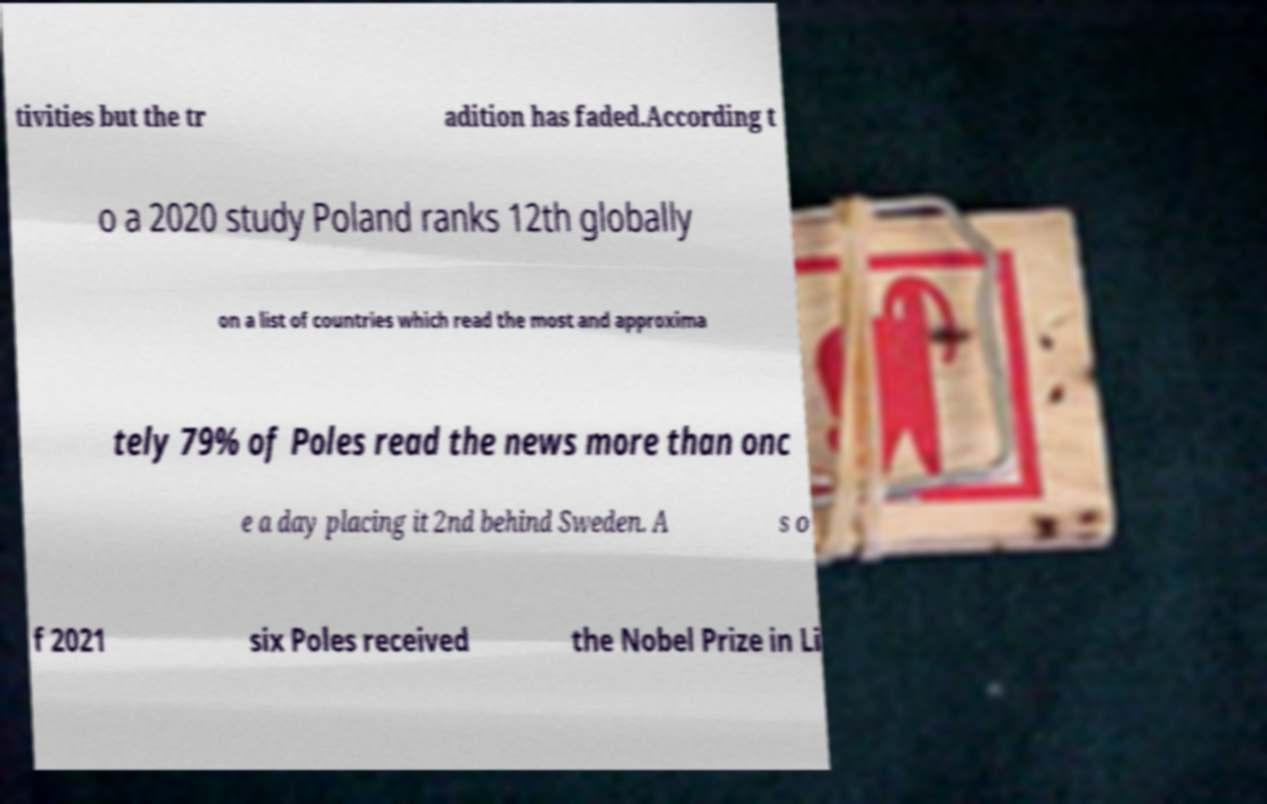I need the written content from this picture converted into text. Can you do that? tivities but the tr adition has faded.According t o a 2020 study Poland ranks 12th globally on a list of countries which read the most and approxima tely 79% of Poles read the news more than onc e a day placing it 2nd behind Sweden. A s o f 2021 six Poles received the Nobel Prize in Li 